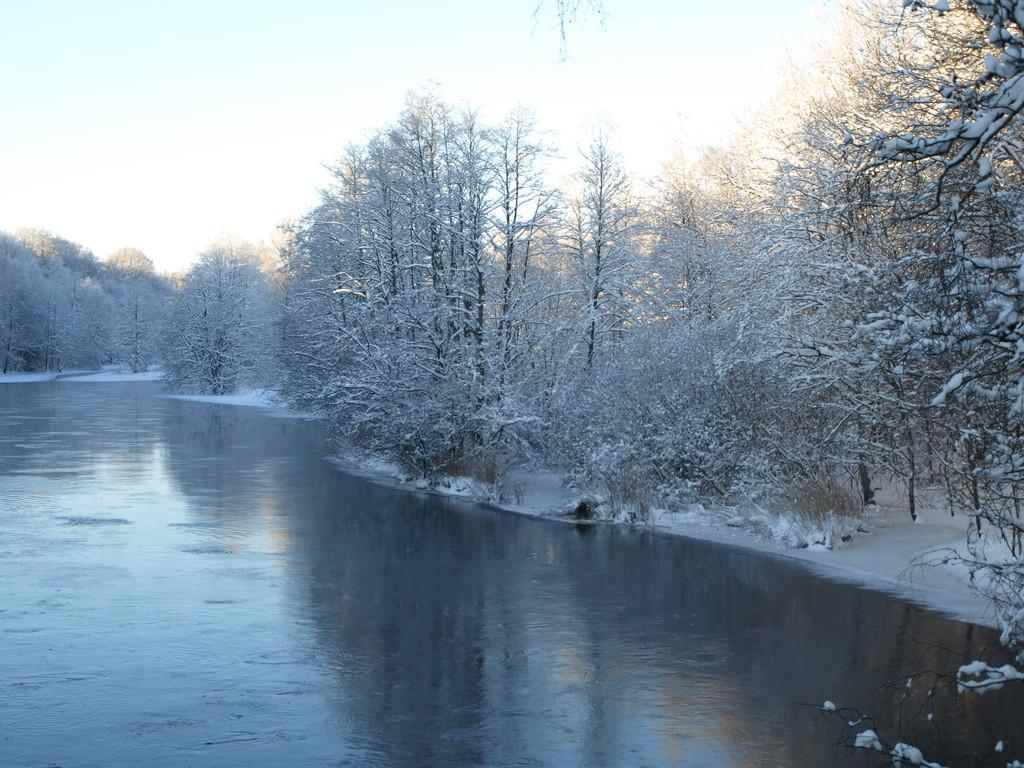What type of vegetation can be seen in the image? There are trees and plants in the image. What natural feature is present in the image? There is a river in the image. What is the weather like in the image? The presence of snow suggests that it is cold in the image. What is visible in the sky in the image? The sky is visible in the image. What type of cloth is draped over the plants in the image? There is no cloth present in the image; it only features trees, plants, a river, snow, and the sky. 